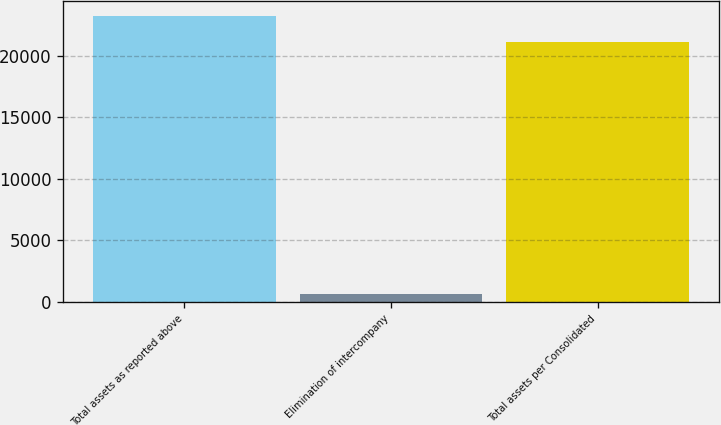Convert chart to OTSL. <chart><loc_0><loc_0><loc_500><loc_500><bar_chart><fcel>Total assets as reported above<fcel>Elimination of intercompany<fcel>Total assets per Consolidated<nl><fcel>23248.5<fcel>588<fcel>21135<nl></chart> 